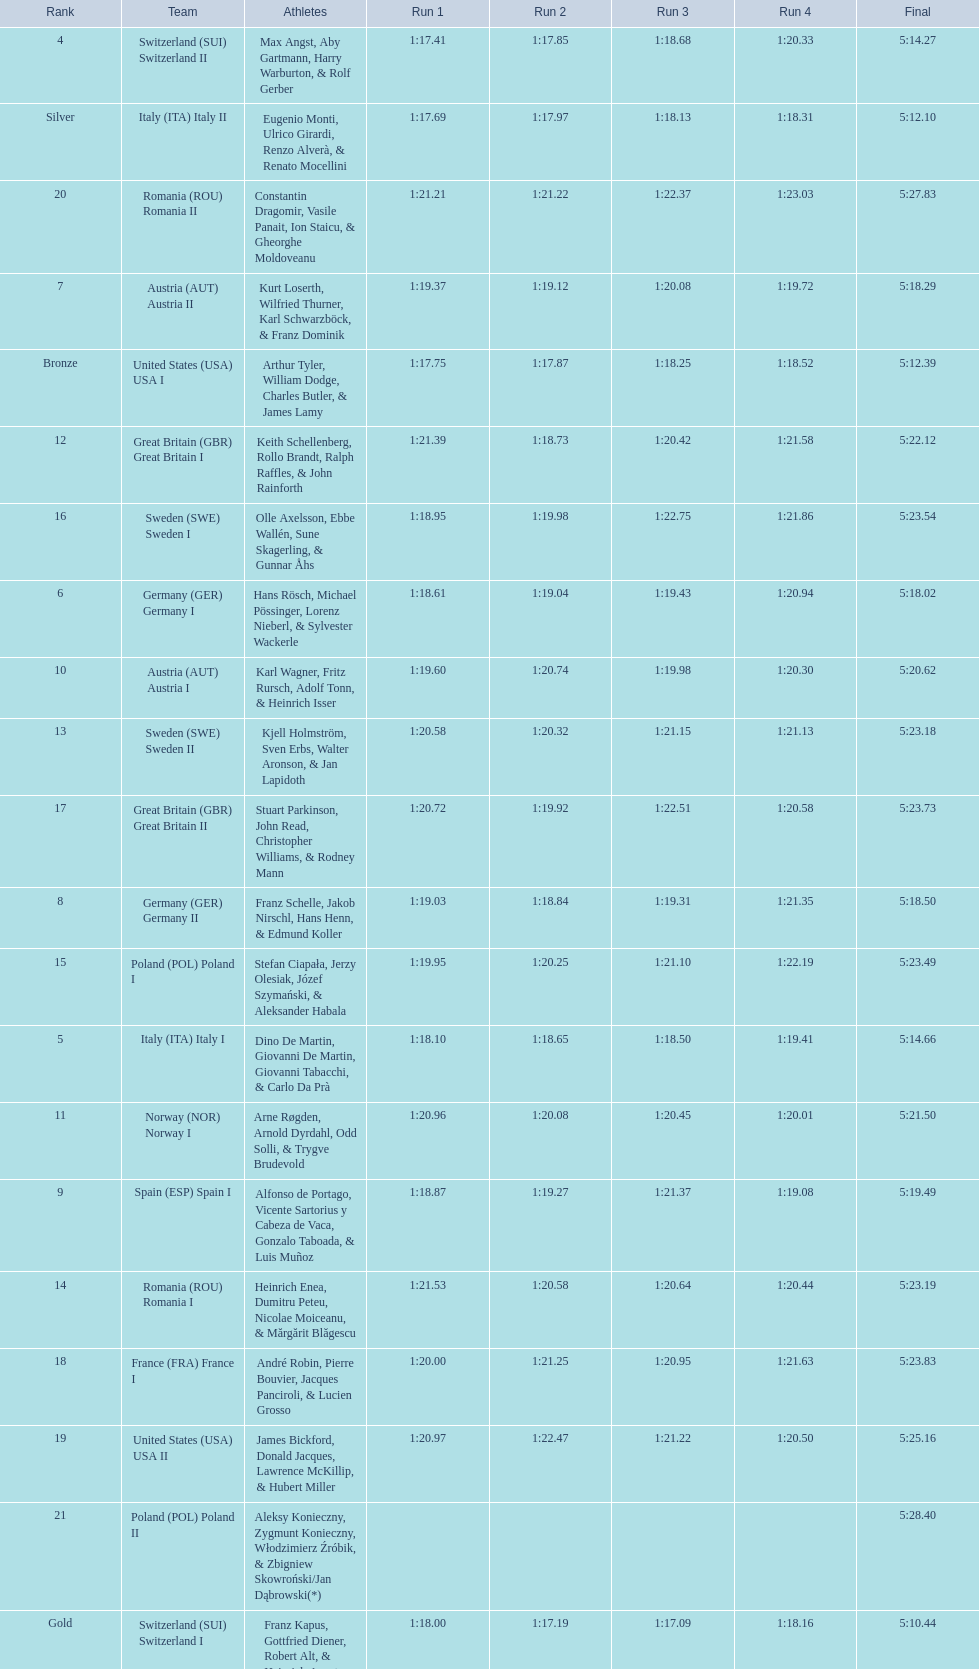What is the total amount of runs? 4. 